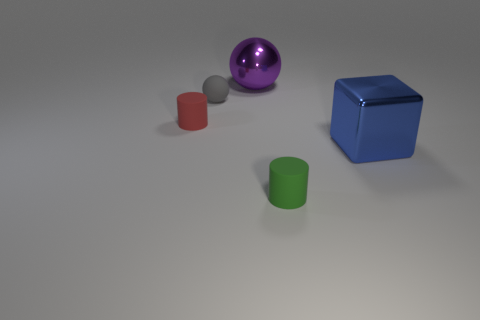The large thing behind the red matte object is what color?
Provide a short and direct response. Purple. There is a metal object right of the tiny green object; is it the same color as the small sphere?
Your response must be concise. No. What is the material of the other small thing that is the same shape as the red object?
Provide a succinct answer. Rubber. What number of yellow shiny cylinders have the same size as the metal ball?
Give a very brief answer. 0. What shape is the tiny gray thing?
Your answer should be compact. Sphere. There is a object that is in front of the gray sphere and behind the large blue cube; how big is it?
Make the answer very short. Small. What material is the small thing left of the small gray object?
Ensure brevity in your answer.  Rubber. There is a shiny ball; is it the same color as the shiny thing that is in front of the red cylinder?
Offer a very short reply. No. How many things are shiny things that are behind the blue metallic block or small cylinders that are left of the large purple metallic object?
Offer a terse response. 2. What color is the thing that is both right of the big ball and on the left side of the cube?
Ensure brevity in your answer.  Green. 